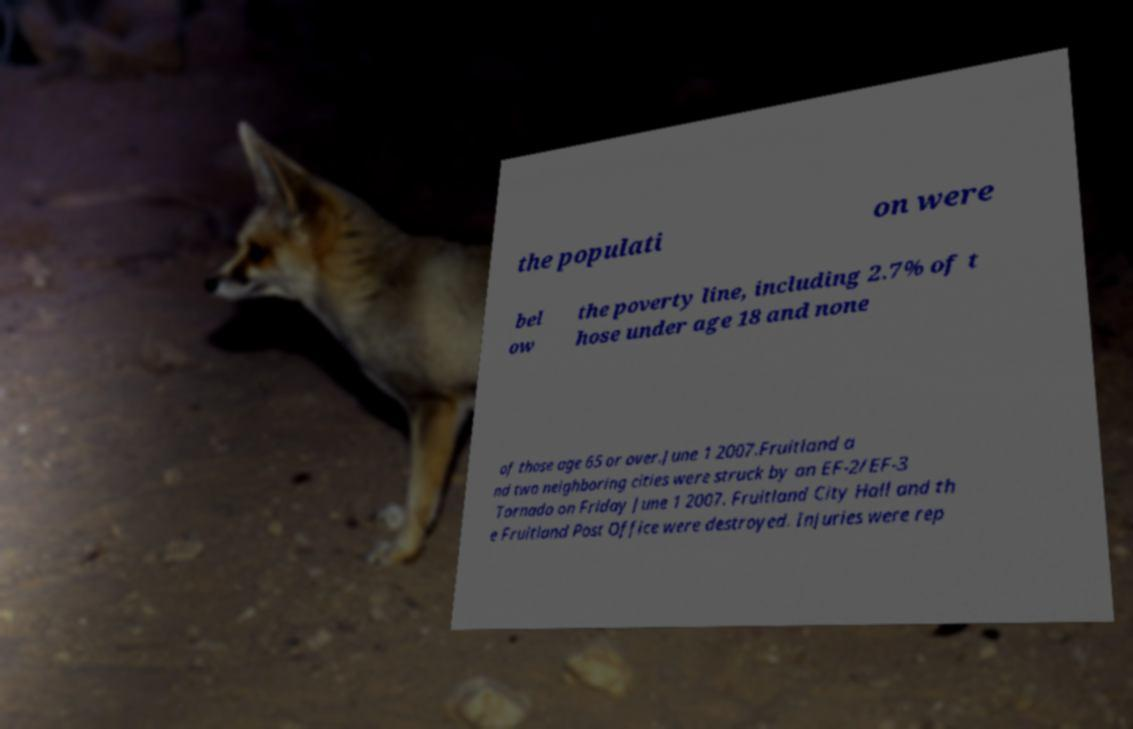Please identify and transcribe the text found in this image. the populati on were bel ow the poverty line, including 2.7% of t hose under age 18 and none of those age 65 or over.June 1 2007.Fruitland a nd two neighboring cities were struck by an EF-2/EF-3 Tornado on Friday June 1 2007. Fruitland City Hall and th e Fruitland Post Office were destroyed. Injuries were rep 